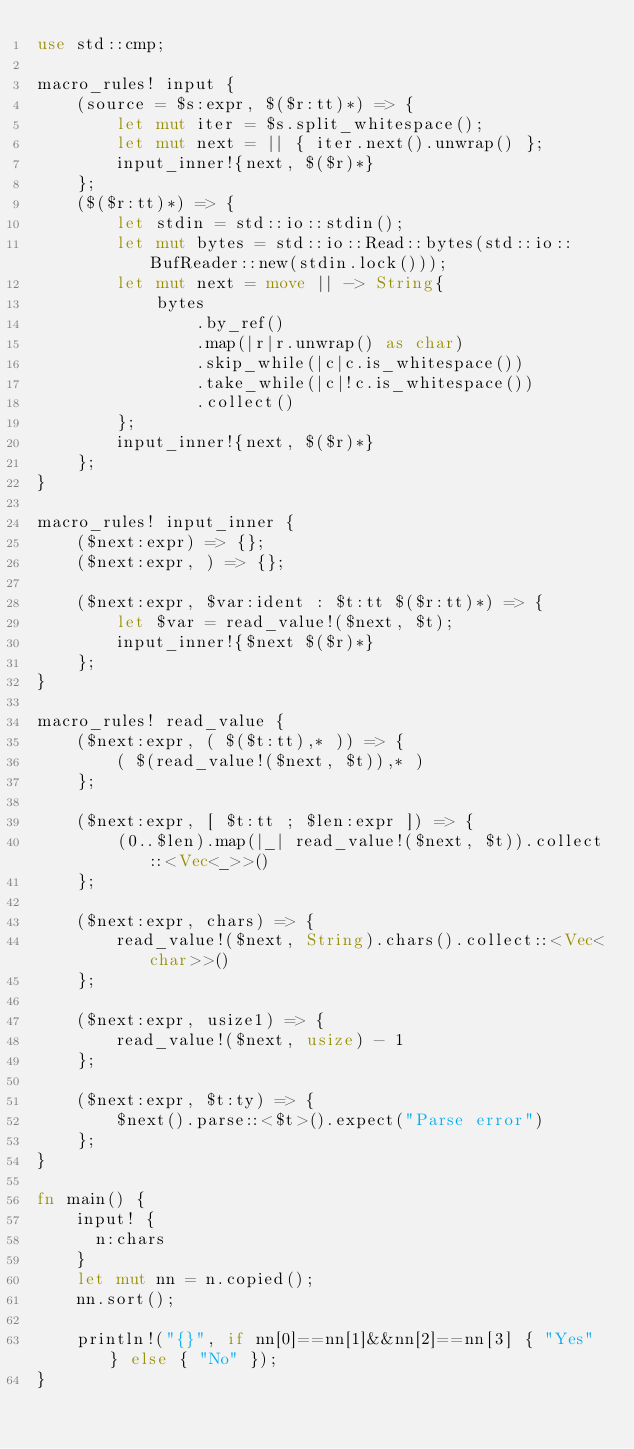Convert code to text. <code><loc_0><loc_0><loc_500><loc_500><_Rust_>use std::cmp;

macro_rules! input {
    (source = $s:expr, $($r:tt)*) => {
        let mut iter = $s.split_whitespace();
        let mut next = || { iter.next().unwrap() };
        input_inner!{next, $($r)*}
    };
    ($($r:tt)*) => {
        let stdin = std::io::stdin();
        let mut bytes = std::io::Read::bytes(std::io::BufReader::new(stdin.lock()));
        let mut next = move || -> String{
            bytes
                .by_ref()
                .map(|r|r.unwrap() as char)
                .skip_while(|c|c.is_whitespace())
                .take_while(|c|!c.is_whitespace())
                .collect()
        };
        input_inner!{next, $($r)*}
    };
}

macro_rules! input_inner {
    ($next:expr) => {};
    ($next:expr, ) => {};

    ($next:expr, $var:ident : $t:tt $($r:tt)*) => {
        let $var = read_value!($next, $t);
        input_inner!{$next $($r)*}
    };
}

macro_rules! read_value {
    ($next:expr, ( $($t:tt),* )) => {
        ( $(read_value!($next, $t)),* )
    };

    ($next:expr, [ $t:tt ; $len:expr ]) => {
        (0..$len).map(|_| read_value!($next, $t)).collect::<Vec<_>>()
    };

    ($next:expr, chars) => {
        read_value!($next, String).chars().collect::<Vec<char>>()
    };

    ($next:expr, usize1) => {
        read_value!($next, usize) - 1
    };

    ($next:expr, $t:ty) => {
        $next().parse::<$t>().expect("Parse error")
    };
}

fn main() {
    input! {
    	n:chars
    }
    let mut nn = n.copied();
    nn.sort();
       
    println!("{}", if nn[0]==nn[1]&&nn[2]==nn[3] { "Yes" } else { "No" });
}</code> 